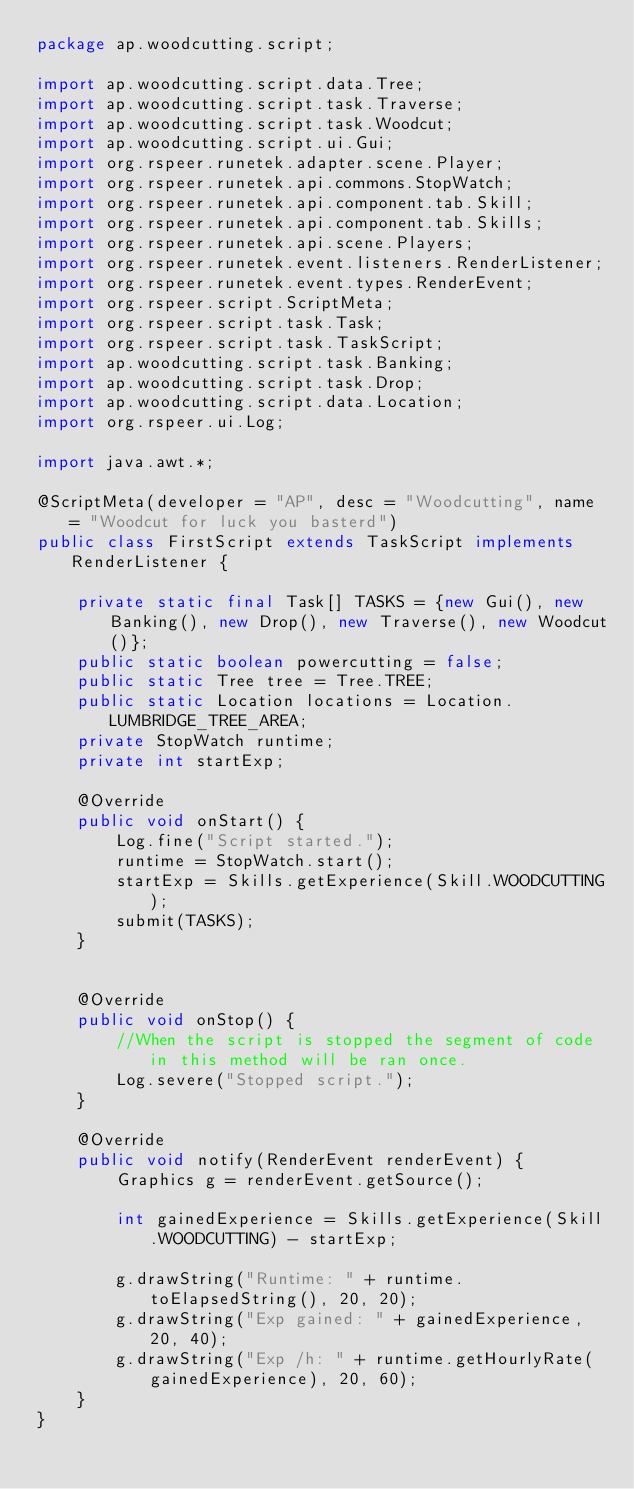<code> <loc_0><loc_0><loc_500><loc_500><_Java_>package ap.woodcutting.script;

import ap.woodcutting.script.data.Tree;
import ap.woodcutting.script.task.Traverse;
import ap.woodcutting.script.task.Woodcut;
import ap.woodcutting.script.ui.Gui;
import org.rspeer.runetek.adapter.scene.Player;
import org.rspeer.runetek.api.commons.StopWatch;
import org.rspeer.runetek.api.component.tab.Skill;
import org.rspeer.runetek.api.component.tab.Skills;
import org.rspeer.runetek.api.scene.Players;
import org.rspeer.runetek.event.listeners.RenderListener;
import org.rspeer.runetek.event.types.RenderEvent;
import org.rspeer.script.ScriptMeta;
import org.rspeer.script.task.Task;
import org.rspeer.script.task.TaskScript;
import ap.woodcutting.script.task.Banking;
import ap.woodcutting.script.task.Drop;
import ap.woodcutting.script.data.Location;
import org.rspeer.ui.Log;

import java.awt.*;

@ScriptMeta(developer = "AP", desc = "Woodcutting", name = "Woodcut for luck you basterd")
public class FirstScript extends TaskScript implements RenderListener {

    private static final Task[] TASKS = {new Gui(), new Banking(), new Drop(), new Traverse(), new Woodcut()};
    public static boolean powercutting = false;
    public static Tree tree = Tree.TREE;
    public static Location locations = Location.LUMBRIDGE_TREE_AREA;
    private StopWatch runtime;
    private int startExp;

    @Override
    public void onStart() {
        Log.fine("Script started.");
        runtime = StopWatch.start();
        startExp = Skills.getExperience(Skill.WOODCUTTING);
        submit(TASKS);
    }


    @Override
    public void onStop() {
        //When the script is stopped the segment of code in this method will be ran once.
        Log.severe("Stopped script.");
    }

    @Override
    public void notify(RenderEvent renderEvent) {
        Graphics g = renderEvent.getSource();

        int gainedExperience = Skills.getExperience(Skill.WOODCUTTING) - startExp;

        g.drawString("Runtime: " + runtime.toElapsedString(), 20, 20);
        g.drawString("Exp gained: " + gainedExperience, 20, 40);
        g.drawString("Exp /h: " + runtime.getHourlyRate(gainedExperience), 20, 60);
    }
}
</code> 